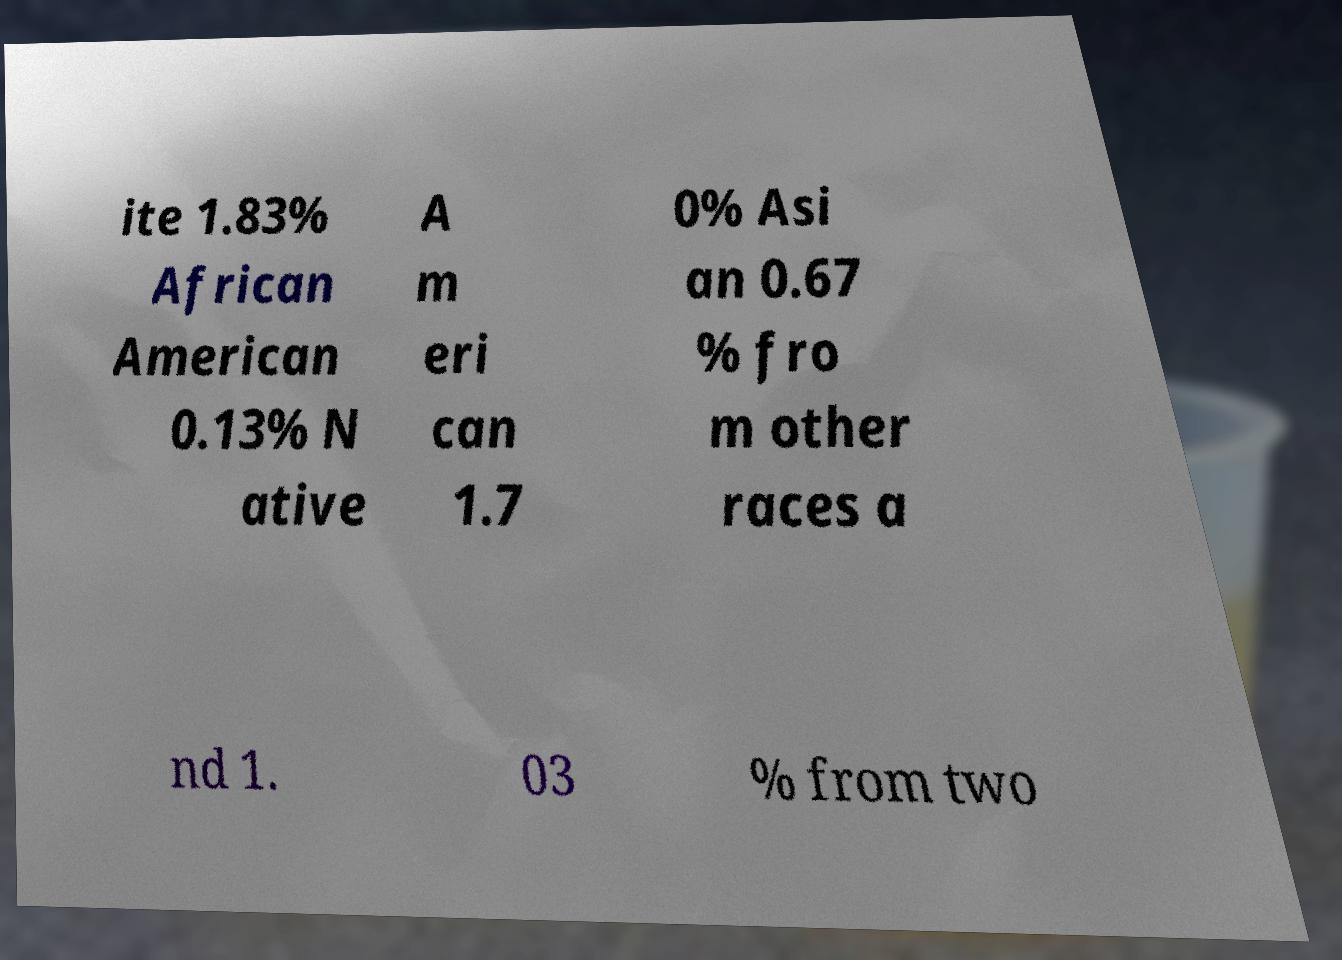Please identify and transcribe the text found in this image. ite 1.83% African American 0.13% N ative A m eri can 1.7 0% Asi an 0.67 % fro m other races a nd 1. 03 % from two 